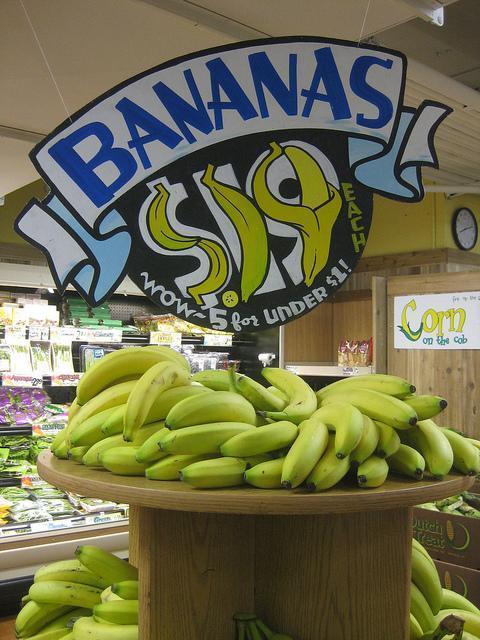How many bananas are in the picture?
Give a very brief answer. 5. How many people are wearing blue tops?
Give a very brief answer. 0. 